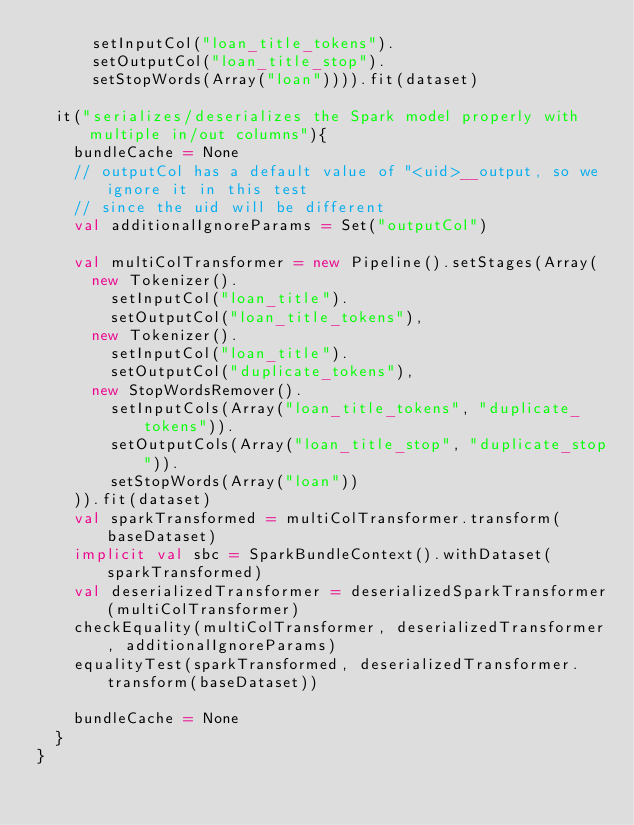<code> <loc_0><loc_0><loc_500><loc_500><_Scala_>      setInputCol("loan_title_tokens").
      setOutputCol("loan_title_stop").
      setStopWords(Array("loan")))).fit(dataset)

  it("serializes/deserializes the Spark model properly with multiple in/out columns"){
    bundleCache = None
    // outputCol has a default value of "<uid>__output, so we ignore it in this test
    // since the uid will be different
    val additionalIgnoreParams = Set("outputCol")

    val multiColTransformer = new Pipeline().setStages(Array(
      new Tokenizer().
        setInputCol("loan_title").
        setOutputCol("loan_title_tokens"),
      new Tokenizer().
        setInputCol("loan_title").
        setOutputCol("duplicate_tokens"),
      new StopWordsRemover().
        setInputCols(Array("loan_title_tokens", "duplicate_tokens")).
        setOutputCols(Array("loan_title_stop", "duplicate_stop")).
        setStopWords(Array("loan"))
    )).fit(dataset)
    val sparkTransformed = multiColTransformer.transform(baseDataset)
    implicit val sbc = SparkBundleContext().withDataset(sparkTransformed)
    val deserializedTransformer = deserializedSparkTransformer(multiColTransformer)
    checkEquality(multiColTransformer, deserializedTransformer, additionalIgnoreParams)
    equalityTest(sparkTransformed, deserializedTransformer.transform(baseDataset))

    bundleCache = None
  }
}
</code> 